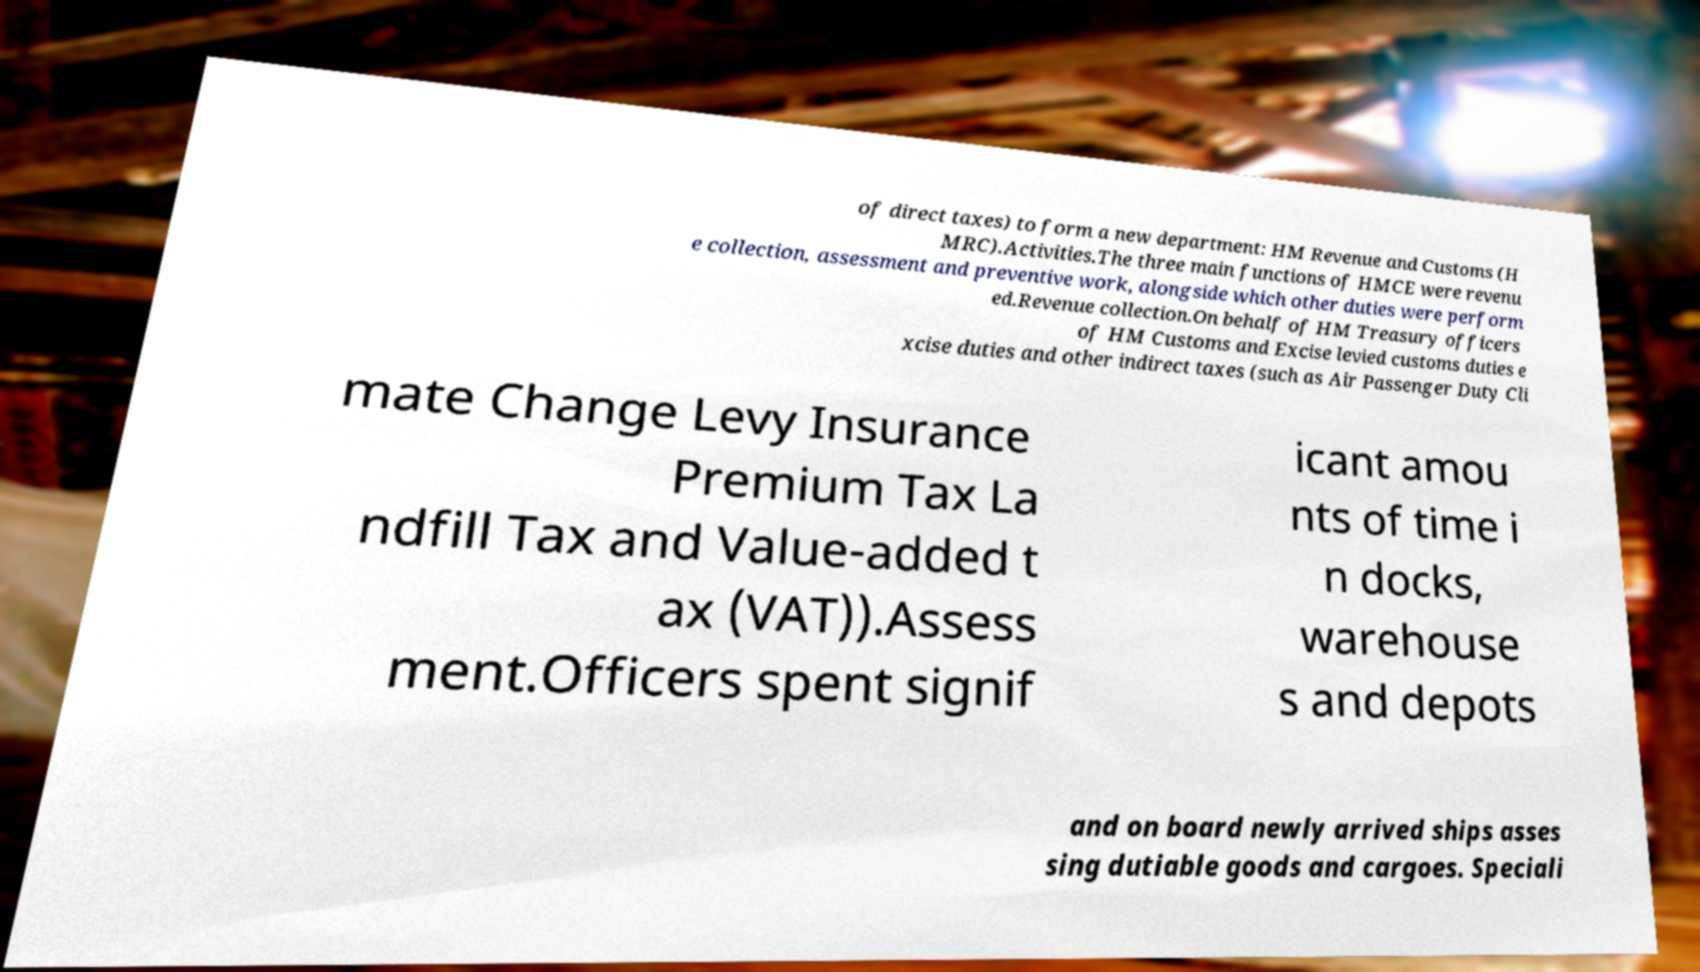Please identify and transcribe the text found in this image. of direct taxes) to form a new department: HM Revenue and Customs (H MRC).Activities.The three main functions of HMCE were revenu e collection, assessment and preventive work, alongside which other duties were perform ed.Revenue collection.On behalf of HM Treasury officers of HM Customs and Excise levied customs duties e xcise duties and other indirect taxes (such as Air Passenger Duty Cli mate Change Levy Insurance Premium Tax La ndfill Tax and Value-added t ax (VAT)).Assess ment.Officers spent signif icant amou nts of time i n docks, warehouse s and depots and on board newly arrived ships asses sing dutiable goods and cargoes. Speciali 